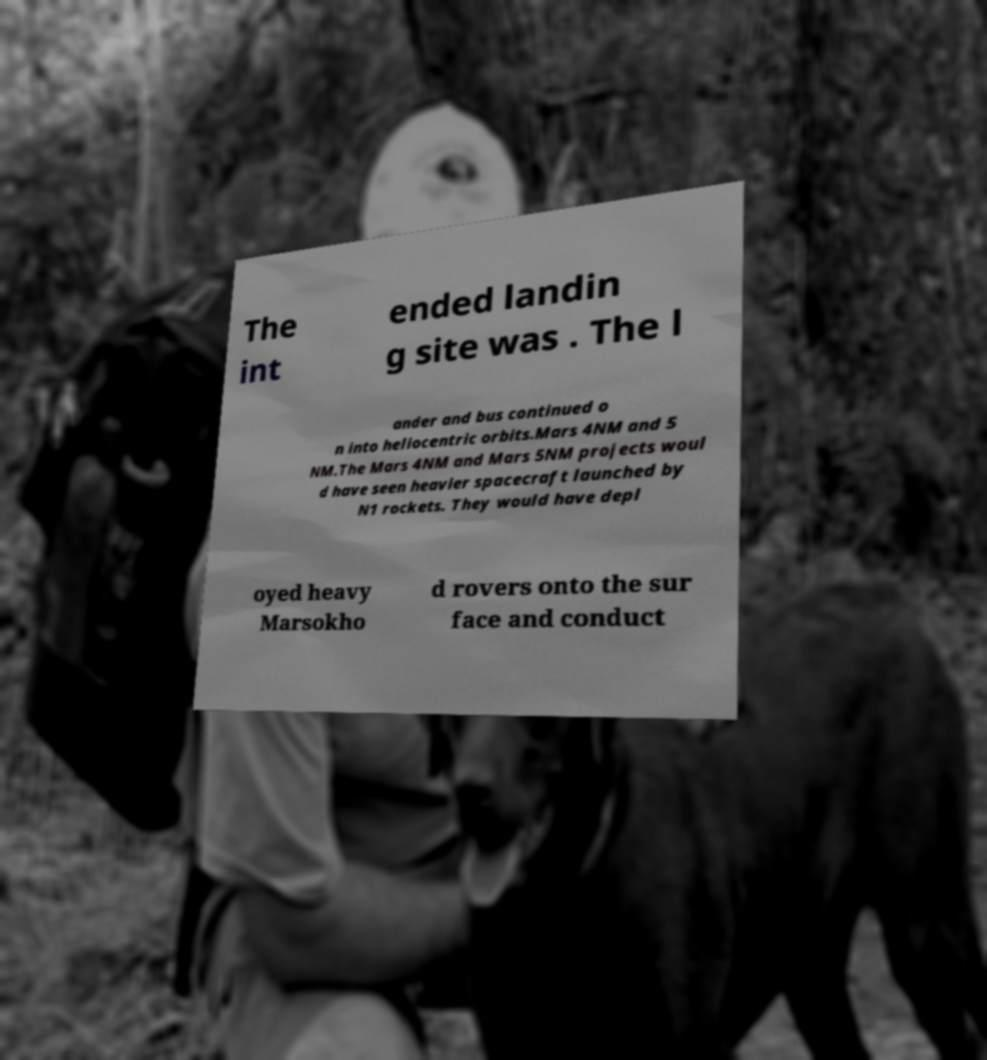Please identify and transcribe the text found in this image. The int ended landin g site was . The l ander and bus continued o n into heliocentric orbits.Mars 4NM and 5 NM.The Mars 4NM and Mars 5NM projects woul d have seen heavier spacecraft launched by N1 rockets. They would have depl oyed heavy Marsokho d rovers onto the sur face and conduct 